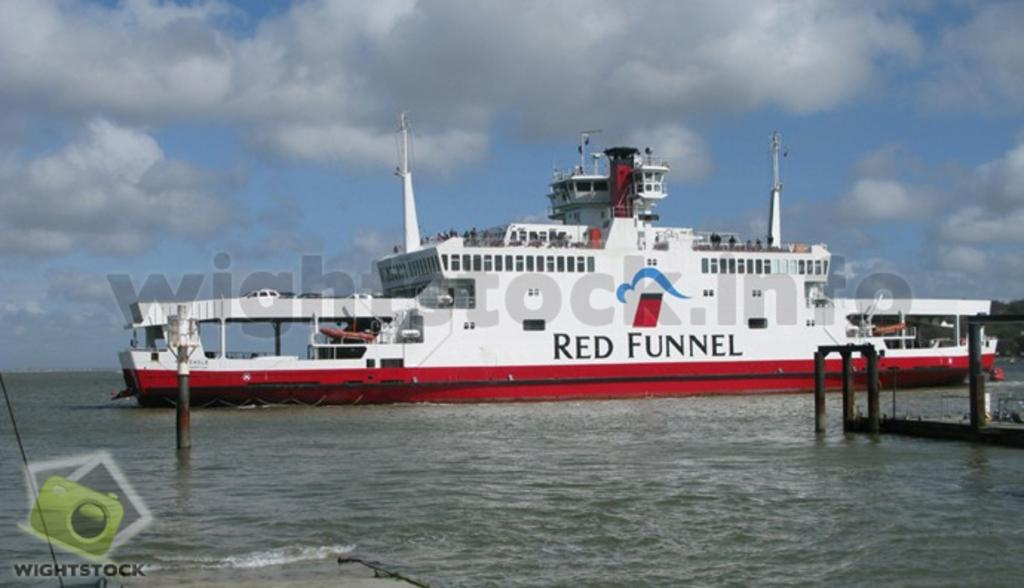What is the main subject of the image? There is a ship in the image. Can you describe the colors of the ship? The ship is white and red in color. What else can be seen in the image besides the ship? There are poles visible in the image. What is the setting of the image? There is water present in the image. What is the color of the sky in the image? The sky is white and blue in color. How many tricks can be performed with the ship in the image? There are no tricks being performed with the ship in the image; it is simply a stationary subject. What type of rest can be seen in the image? There is no rest or resting area visible in the image; it primarily features a ship and its surroundings. 